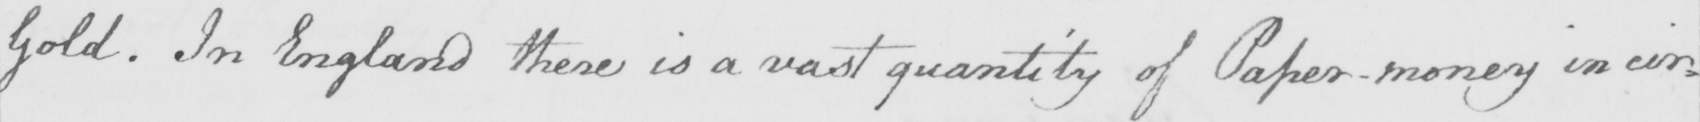Please provide the text content of this handwritten line. Gold . In England there is a vast quantity of Paper-money in cir= 